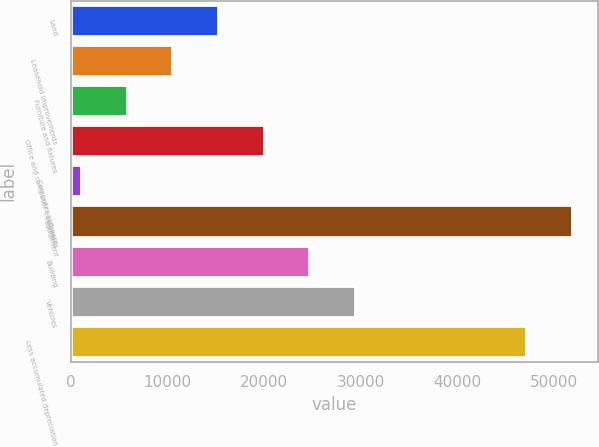<chart> <loc_0><loc_0><loc_500><loc_500><bar_chart><fcel>Land<fcel>Leasehold improvements<fcel>Furniture and fixtures<fcel>Office and computer equipment<fcel>Computer software<fcel>Equipment<fcel>Building<fcel>Vehicles<fcel>Less accumulated depreciation<nl><fcel>15322.6<fcel>10593.4<fcel>5864.2<fcel>20051.8<fcel>1135<fcel>51939.2<fcel>24781<fcel>29510.2<fcel>47210<nl></chart> 